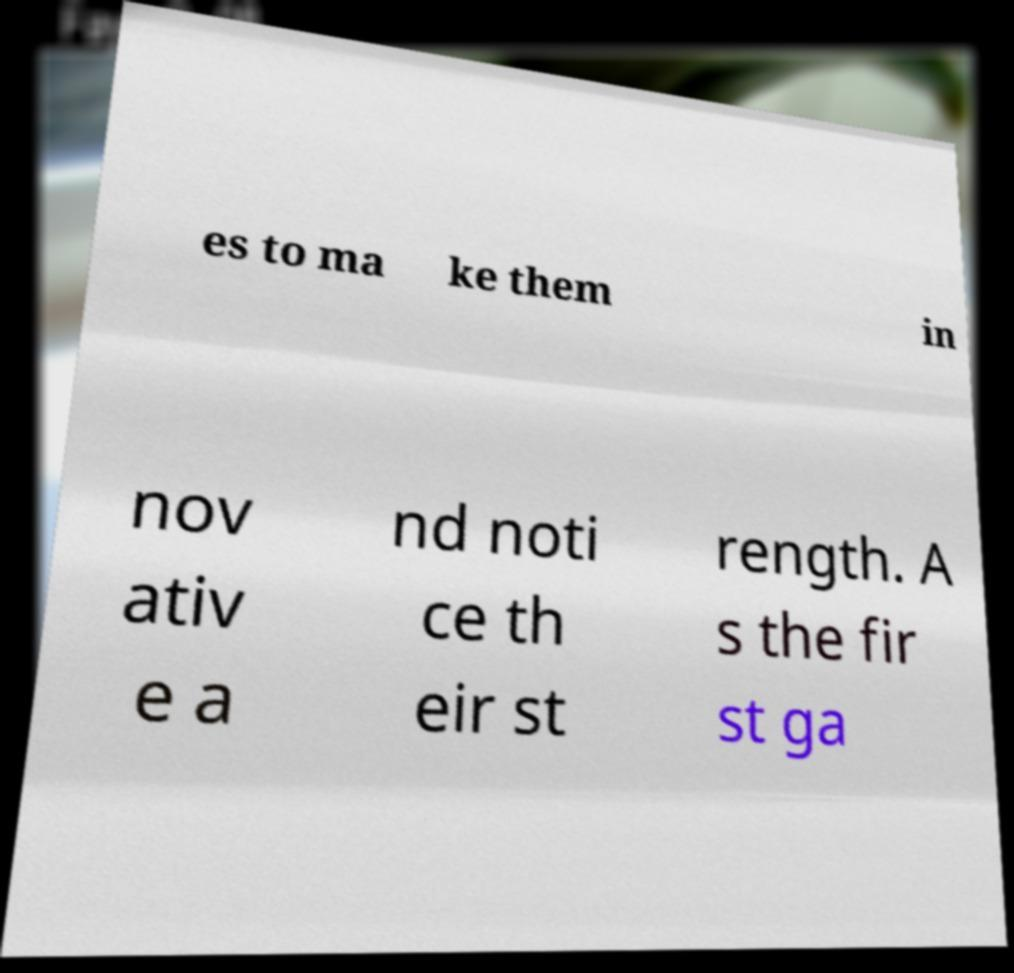Please read and relay the text visible in this image. What does it say? es to ma ke them in nov ativ e a nd noti ce th eir st rength. A s the fir st ga 